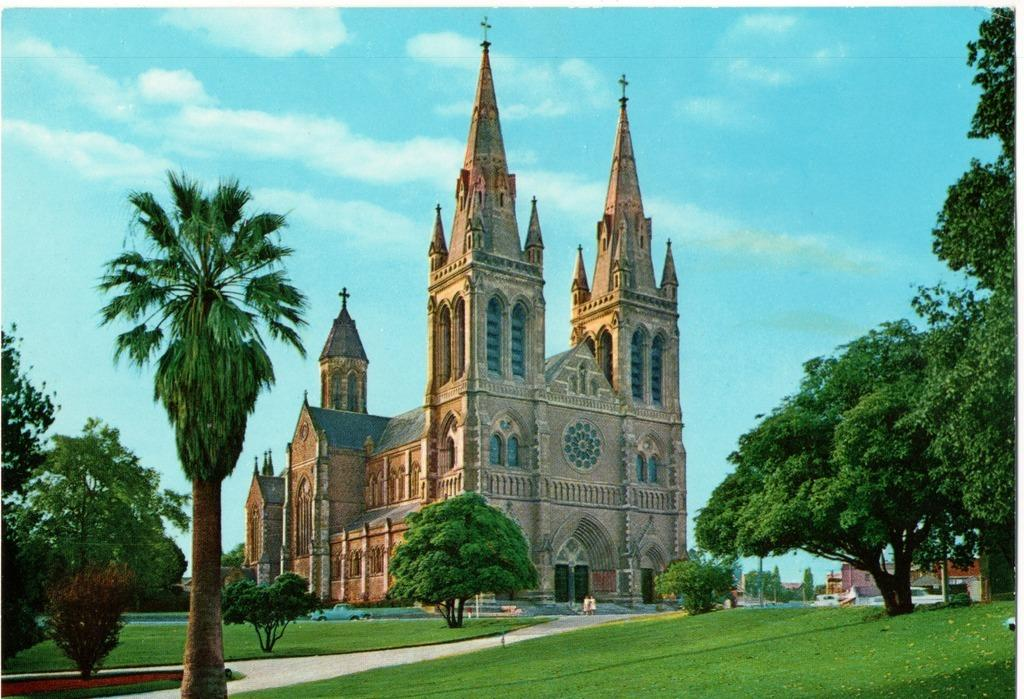What type of structures can be seen in the image? There are buildings in the image. What other natural elements are present in the image? There are trees in the image. How would you describe the sky in the image? The sky is blue and cloudy in the image. What type of ground surface is visible in the image? There is grass on the ground in the image. How many friends are sitting on the grass in the image? There are no friends sitting on the grass in the image; it only shows buildings, trees, and a blue, cloudy sky. 